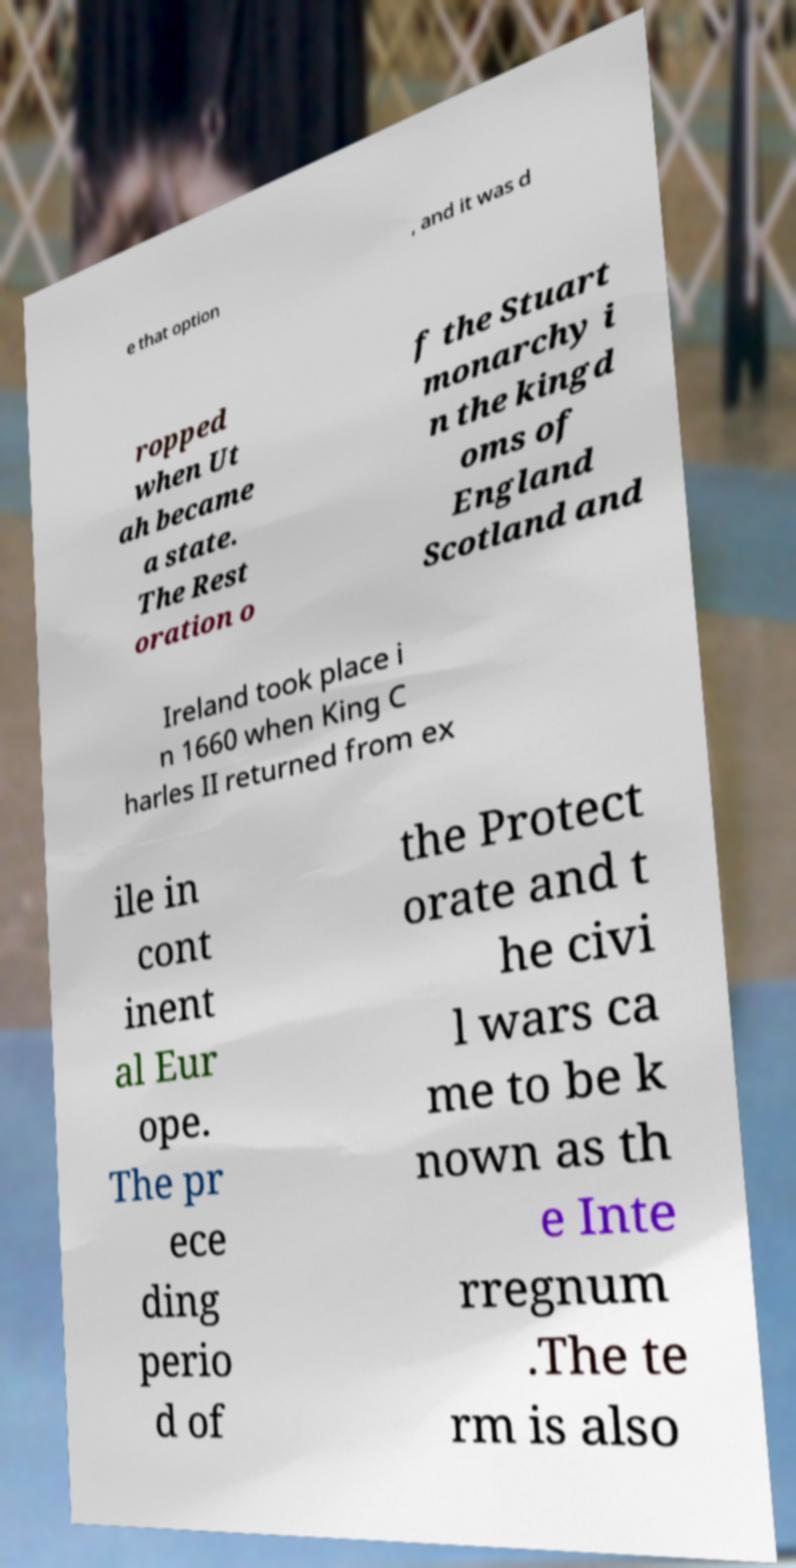Could you assist in decoding the text presented in this image and type it out clearly? e that option , and it was d ropped when Ut ah became a state. The Rest oration o f the Stuart monarchy i n the kingd oms of England Scotland and Ireland took place i n 1660 when King C harles II returned from ex ile in cont inent al Eur ope. The pr ece ding perio d of the Protect orate and t he civi l wars ca me to be k nown as th e Inte rregnum .The te rm is also 